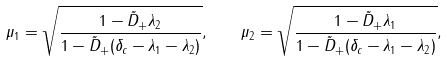Convert formula to latex. <formula><loc_0><loc_0><loc_500><loc_500>\mu _ { 1 } = \sqrt { \frac { 1 - \tilde { D } _ { + } \lambda _ { 2 } } { 1 - \tilde { D } _ { + } ( \delta _ { c } - \lambda _ { 1 } - \lambda _ { 2 } ) } } , \quad \mu _ { 2 } = \sqrt { \frac { 1 - \tilde { D } _ { + } \lambda _ { 1 } } { 1 - \tilde { D } _ { + } ( \delta _ { c } - \lambda _ { 1 } - \lambda _ { 2 } ) } } ,</formula> 